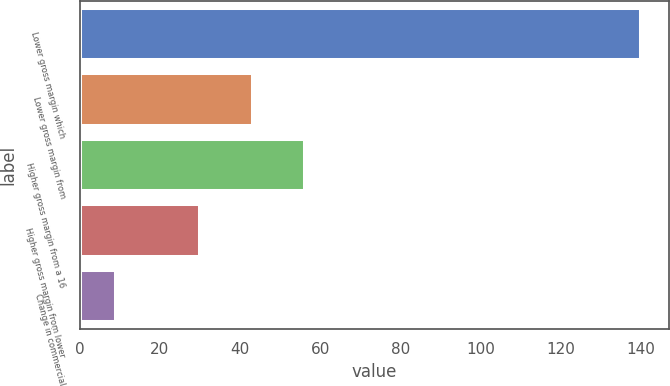Convert chart. <chart><loc_0><loc_0><loc_500><loc_500><bar_chart><fcel>Lower gross margin which<fcel>Lower gross margin from<fcel>Higher gross margin from a 16<fcel>Higher gross margin from lower<fcel>Change in commercial<nl><fcel>140<fcel>43.1<fcel>56.2<fcel>30<fcel>9<nl></chart> 